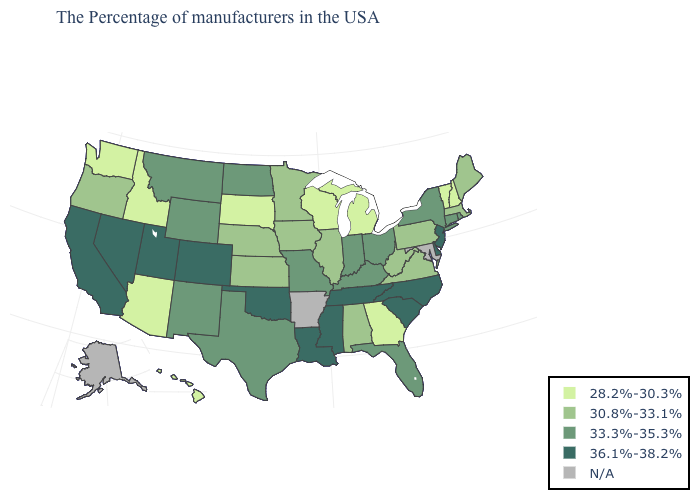Name the states that have a value in the range 33.3%-35.3%?
Write a very short answer. Rhode Island, Connecticut, New York, Ohio, Florida, Kentucky, Indiana, Missouri, Texas, North Dakota, Wyoming, New Mexico, Montana. How many symbols are there in the legend?
Write a very short answer. 5. What is the value of Idaho?
Quick response, please. 28.2%-30.3%. Does the map have missing data?
Be succinct. Yes. Does Kentucky have the lowest value in the South?
Answer briefly. No. Name the states that have a value in the range N/A?
Answer briefly. Maryland, Arkansas, Alaska. Name the states that have a value in the range N/A?
Keep it brief. Maryland, Arkansas, Alaska. Among the states that border Michigan , which have the highest value?
Quick response, please. Ohio, Indiana. Among the states that border Arkansas , does Tennessee have the highest value?
Write a very short answer. Yes. What is the value of Wisconsin?
Keep it brief. 28.2%-30.3%. Which states have the lowest value in the MidWest?
Give a very brief answer. Michigan, Wisconsin, South Dakota. What is the lowest value in the USA?
Answer briefly. 28.2%-30.3%. What is the value of Kentucky?
Short answer required. 33.3%-35.3%. Name the states that have a value in the range 33.3%-35.3%?
Be succinct. Rhode Island, Connecticut, New York, Ohio, Florida, Kentucky, Indiana, Missouri, Texas, North Dakota, Wyoming, New Mexico, Montana. 